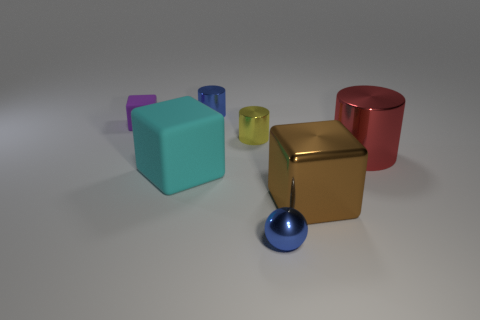Add 2 small brown metallic things. How many objects exist? 9 Subtract all spheres. How many objects are left? 6 Add 2 tiny gray balls. How many tiny gray balls exist? 2 Subtract 0 cyan cylinders. How many objects are left? 7 Subtract all big red shiny cylinders. Subtract all big red metal objects. How many objects are left? 5 Add 2 red shiny cylinders. How many red shiny cylinders are left? 3 